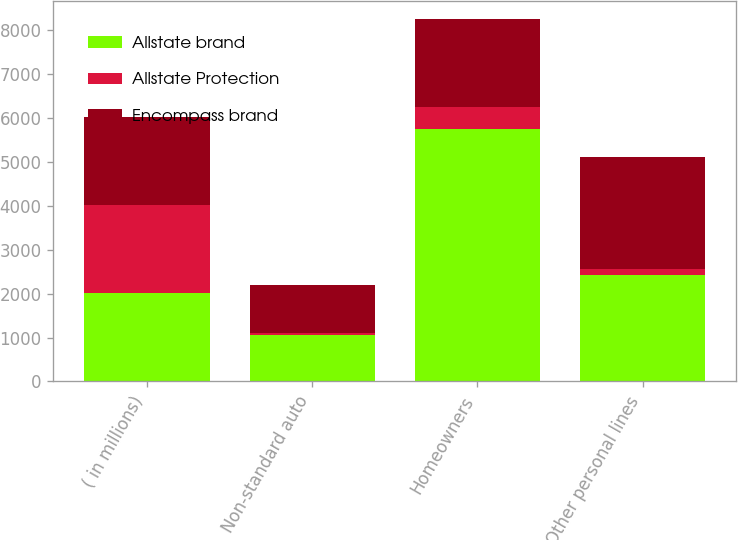<chart> <loc_0><loc_0><loc_500><loc_500><stacked_bar_chart><ecel><fcel>( in millions)<fcel>Non-standard auto<fcel>Homeowners<fcel>Other personal lines<nl><fcel>Allstate brand<fcel>2008<fcel>1055<fcel>5758<fcel>2434<nl><fcel>Allstate Protection<fcel>2008<fcel>45<fcel>503<fcel>124<nl><fcel>Encompass brand<fcel>2008<fcel>1100<fcel>2008<fcel>2558<nl></chart> 